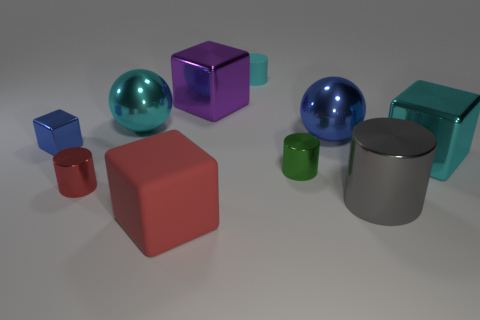What material is the large gray object that is the same shape as the small cyan rubber object?
Offer a terse response. Metal. There is a cylinder right of the big metallic ball to the right of the tiny green shiny thing; what size is it?
Provide a short and direct response. Large. How many things are metallic objects or small rubber cylinders?
Provide a succinct answer. 9. Does the big gray object have the same shape as the small green object?
Provide a short and direct response. Yes. Is there a large purple cube that has the same material as the red cylinder?
Provide a short and direct response. Yes. Is there a big metal object on the left side of the cyan shiny thing right of the large shiny cylinder?
Offer a very short reply. Yes. There is a cyan metallic object to the left of the purple cube; does it have the same size as the tiny matte cylinder?
Ensure brevity in your answer.  No. What size is the red shiny cylinder?
Make the answer very short. Small. Are there any other small objects of the same color as the tiny matte thing?
Keep it short and to the point. No. What number of large objects are red metal things or red rubber blocks?
Make the answer very short. 1. 